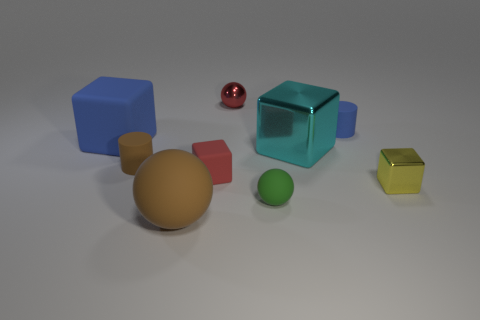Add 1 small metal spheres. How many objects exist? 10 Subtract all balls. How many objects are left? 6 Subtract all large blue cylinders. Subtract all green spheres. How many objects are left? 8 Add 2 blue rubber cylinders. How many blue rubber cylinders are left? 3 Add 5 big cyan blocks. How many big cyan blocks exist? 6 Subtract 1 yellow blocks. How many objects are left? 8 